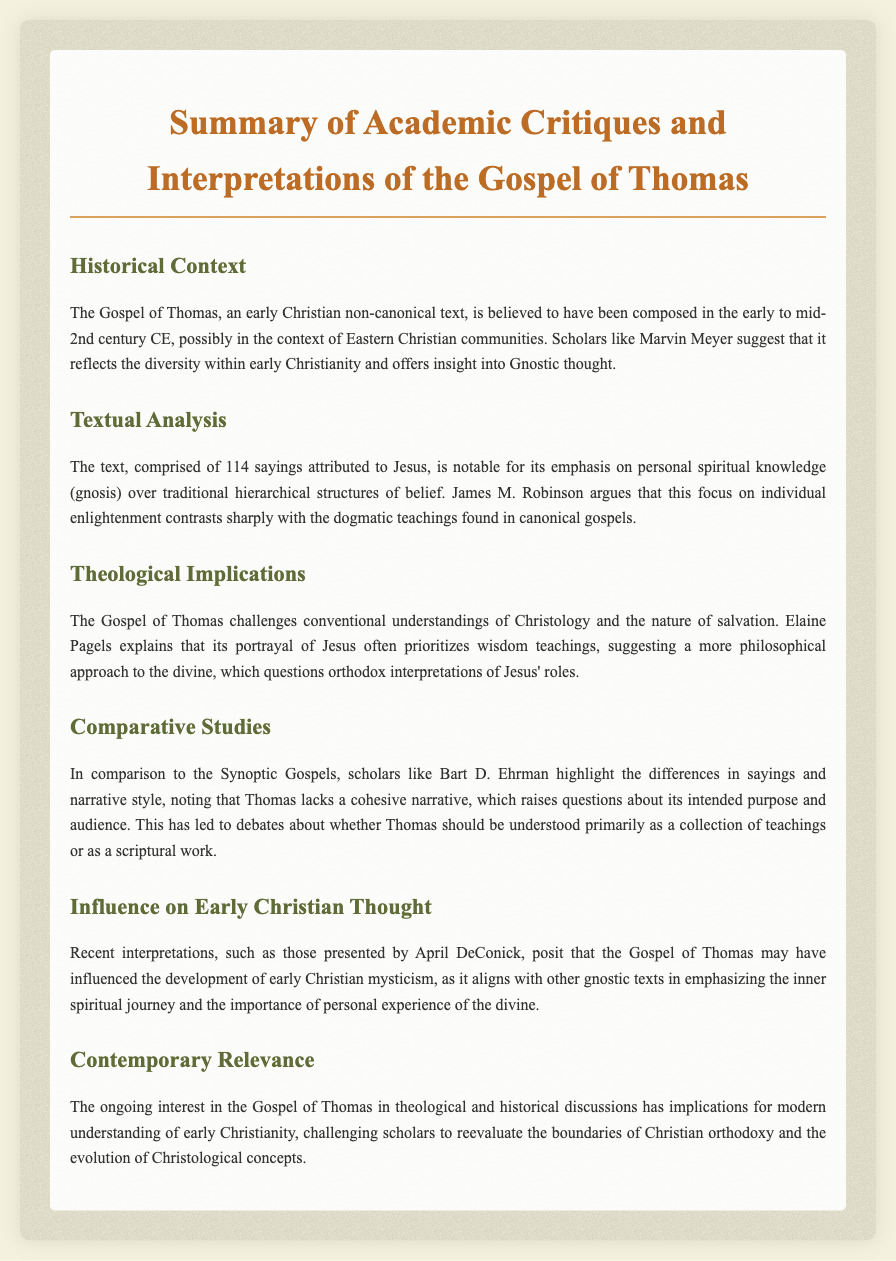What is the Gospel of Thomas? The Gospel of Thomas is an early Christian non-canonical text.
Answer: early Christian non-canonical text In which century is the Gospel of Thomas believed to have been composed? It is believed to have been composed in the early to mid-2nd century CE.
Answer: early to mid-2nd century CE Who suggested that the Gospel of Thomas reflects diversity within early Christianity? Marvin Meyer suggested this insight.
Answer: Marvin Meyer How many sayings are attributed to Jesus in the Gospel of Thomas? The text comprises 114 sayings attributed to Jesus.
Answer: 114 sayings What does the Gospel of Thomas emphasize over traditional hierarchical structures of belief? It emphasizes personal spiritual knowledge (gnosis).
Answer: personal spiritual knowledge (gnosis) Which scholar highlighted the differences in narrative style between Thomas and the Synoptic Gospels? Bart D. Ehrman highlighted these differences.
Answer: Bart D. Ehrman What theological aspect does Elaine Pagels explain about the Gospel of Thomas? She explains that it prioritizes wisdom teachings of Jesus.
Answer: wisdom teachings Which scholar posited that the Gospel of Thomas may have influenced early Christian mysticism? April DeConick posited this influence.
Answer: April DeConick What does contemporary interest in the Gospel of Thomas challenge regarding early Christianity? It challenges the boundaries of Christian orthodoxy.
Answer: boundaries of Christian orthodoxy 